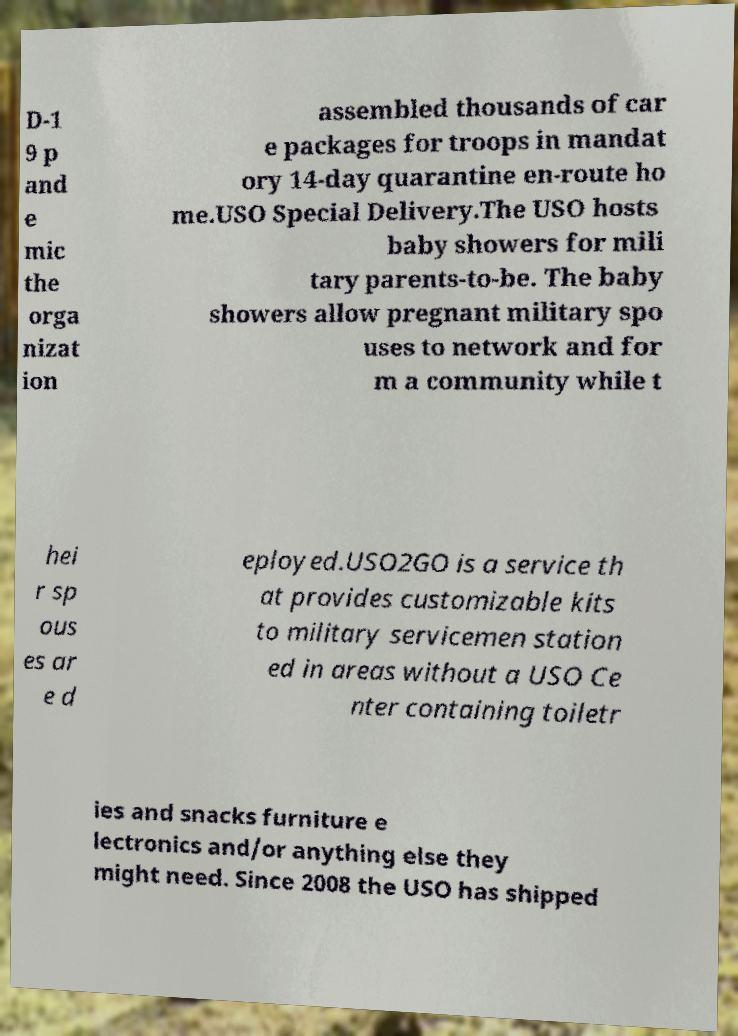Can you read and provide the text displayed in the image?This photo seems to have some interesting text. Can you extract and type it out for me? D-1 9 p and e mic the orga nizat ion assembled thousands of car e packages for troops in mandat ory 14-day quarantine en-route ho me.USO Special Delivery.The USO hosts baby showers for mili tary parents-to-be. The baby showers allow pregnant military spo uses to network and for m a community while t hei r sp ous es ar e d eployed.USO2GO is a service th at provides customizable kits to military servicemen station ed in areas without a USO Ce nter containing toiletr ies and snacks furniture e lectronics and/or anything else they might need. Since 2008 the USO has shipped 